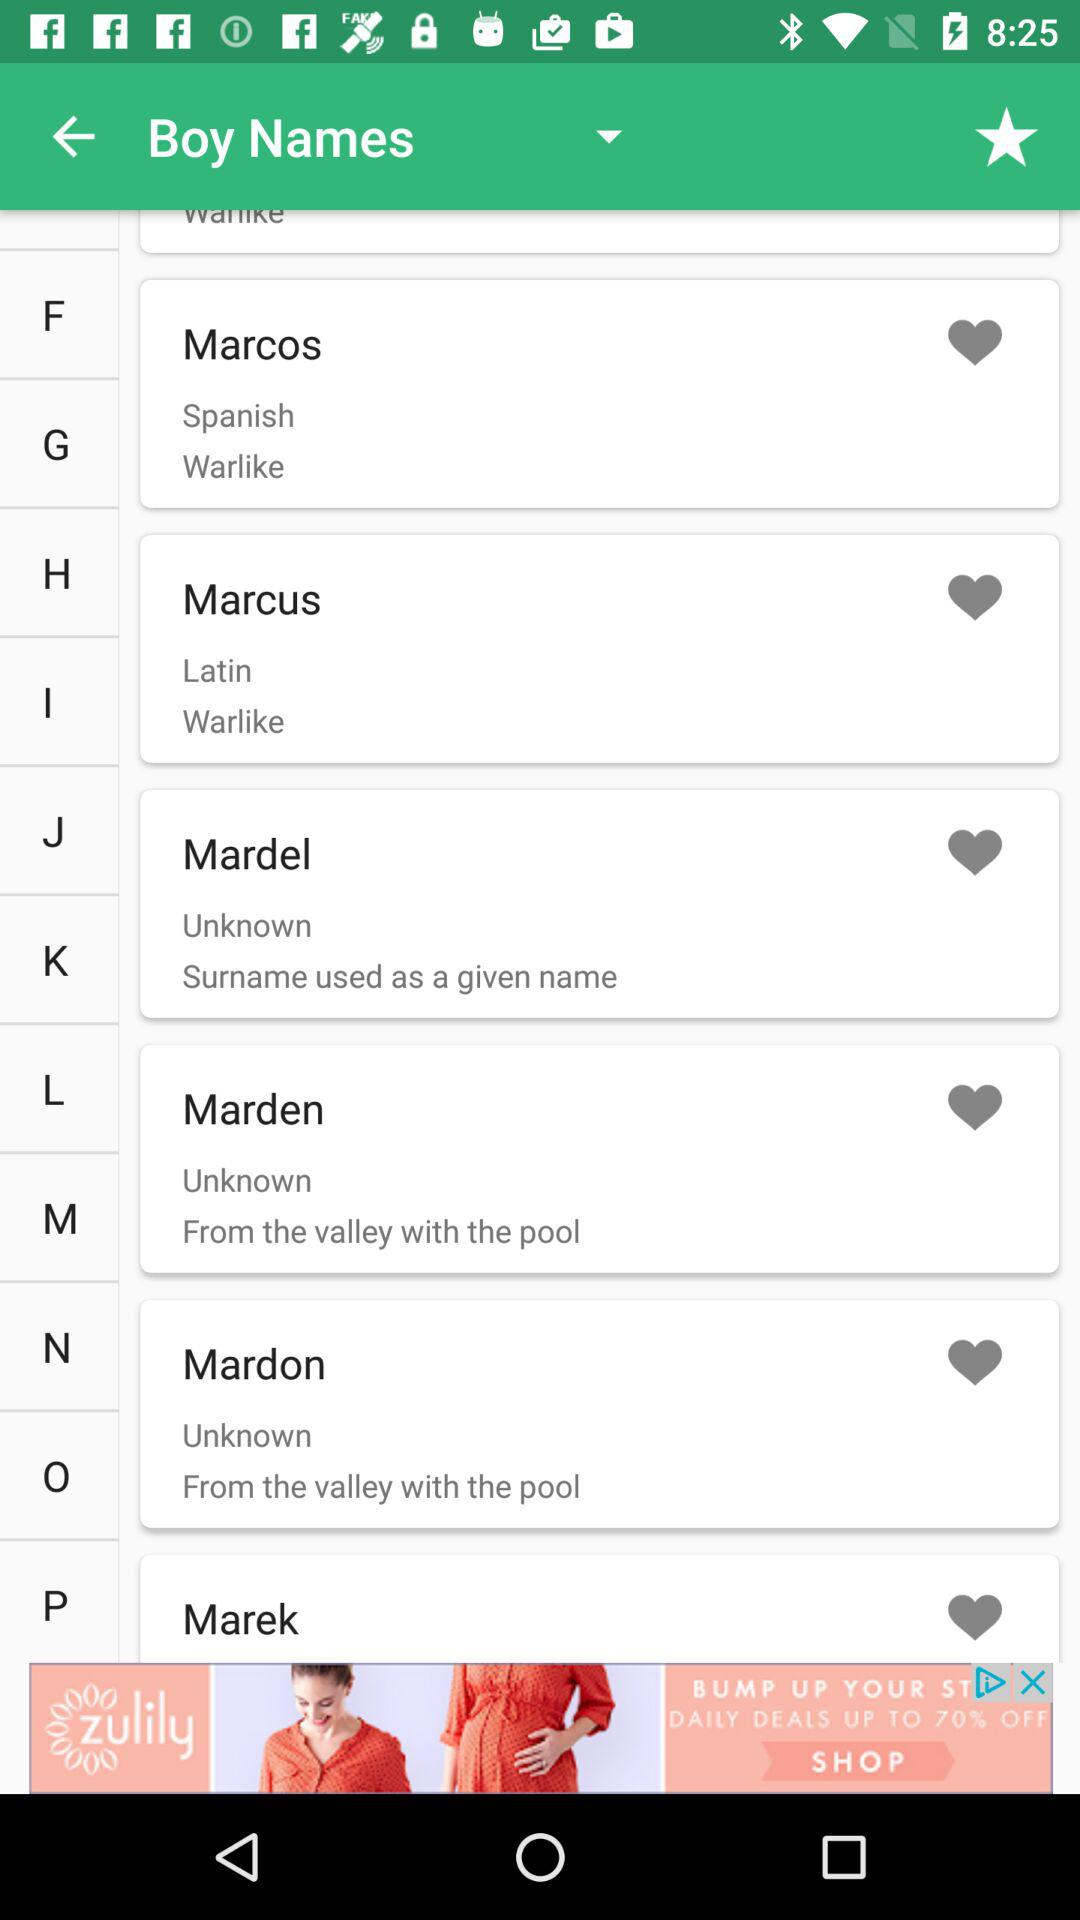What is the boy's Spanish name? The boy's Spanish name is Marcos. 